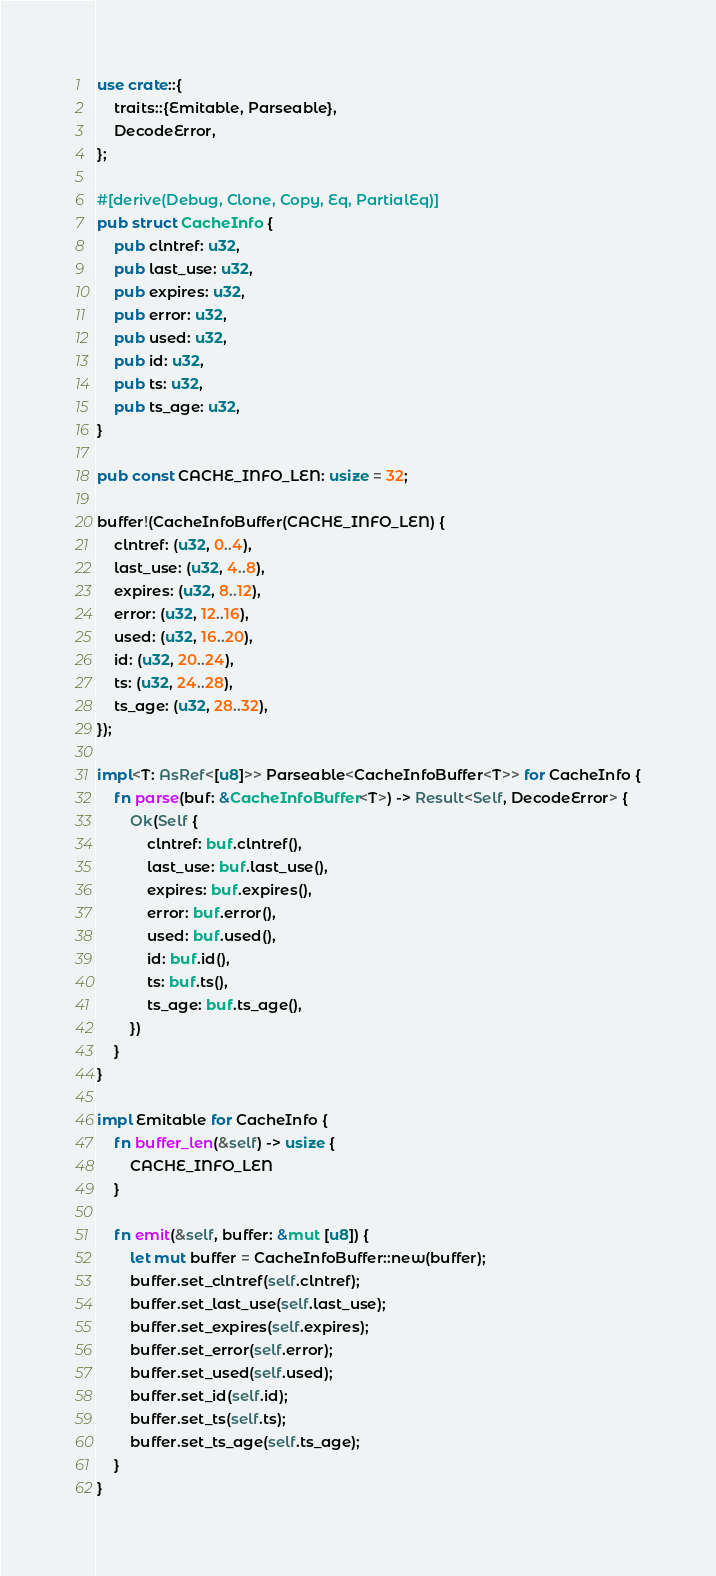<code> <loc_0><loc_0><loc_500><loc_500><_Rust_>use crate::{
    traits::{Emitable, Parseable},
    DecodeError,
};

#[derive(Debug, Clone, Copy, Eq, PartialEq)]
pub struct CacheInfo {
    pub clntref: u32,
    pub last_use: u32,
    pub expires: u32,
    pub error: u32,
    pub used: u32,
    pub id: u32,
    pub ts: u32,
    pub ts_age: u32,
}

pub const CACHE_INFO_LEN: usize = 32;

buffer!(CacheInfoBuffer(CACHE_INFO_LEN) {
    clntref: (u32, 0..4),
    last_use: (u32, 4..8),
    expires: (u32, 8..12),
    error: (u32, 12..16),
    used: (u32, 16..20),
    id: (u32, 20..24),
    ts: (u32, 24..28),
    ts_age: (u32, 28..32),
});

impl<T: AsRef<[u8]>> Parseable<CacheInfoBuffer<T>> for CacheInfo {
    fn parse(buf: &CacheInfoBuffer<T>) -> Result<Self, DecodeError> {
        Ok(Self {
            clntref: buf.clntref(),
            last_use: buf.last_use(),
            expires: buf.expires(),
            error: buf.error(),
            used: buf.used(),
            id: buf.id(),
            ts: buf.ts(),
            ts_age: buf.ts_age(),
        })
    }
}

impl Emitable for CacheInfo {
    fn buffer_len(&self) -> usize {
        CACHE_INFO_LEN
    }

    fn emit(&self, buffer: &mut [u8]) {
        let mut buffer = CacheInfoBuffer::new(buffer);
        buffer.set_clntref(self.clntref);
        buffer.set_last_use(self.last_use);
        buffer.set_expires(self.expires);
        buffer.set_error(self.error);
        buffer.set_used(self.used);
        buffer.set_id(self.id);
        buffer.set_ts(self.ts);
        buffer.set_ts_age(self.ts_age);
    }
}
</code> 